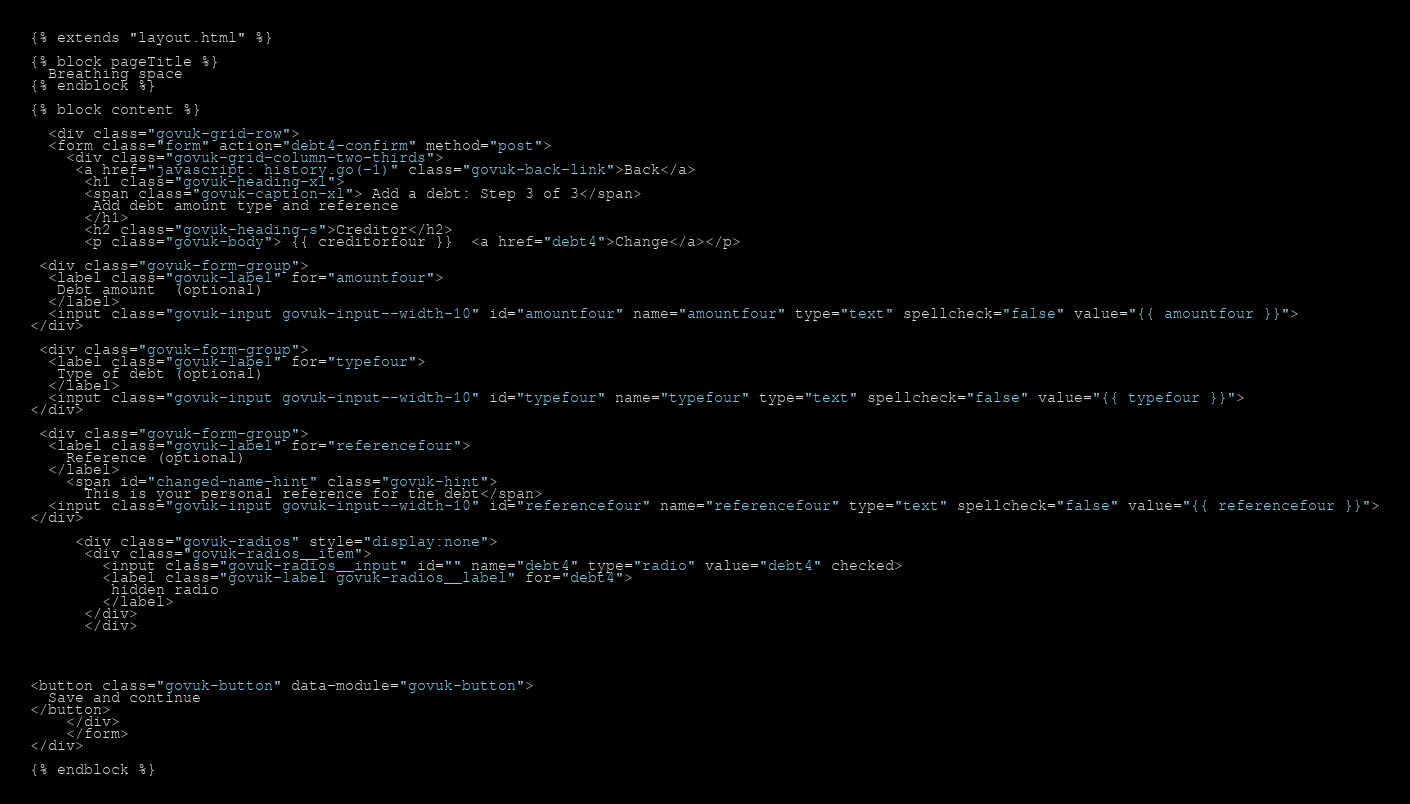Convert code to text. <code><loc_0><loc_0><loc_500><loc_500><_HTML_>
{% extends "layout.html" %}

{% block pageTitle %}
  Breathing space
{% endblock %}

{% block content %}

  <div class="govuk-grid-row">
  <form class="form" action="debt4-confirm" method="post">
    <div class="govuk-grid-column-two-thirds">
     <a href="javascript: history.go(-1)" class="govuk-back-link">Back</a>   
      <h1 class="govuk-heading-xl">
      <span class="govuk-caption-xl"> Add a debt: Step 3 of 3</span>
       Add debt amount type and reference
      </h1>
      <h2 class="govuk-heading-s">Creditor</h2>
      <p class="govuk-body"> {{ creditorfour }}  <a href="debt4">Change</a></p>

 <div class="govuk-form-group">
  <label class="govuk-label" for="amountfour">
   Debt amount  (optional)
  </label>
  <input class="govuk-input govuk-input--width-10" id="amountfour" name="amountfour" type="text" spellcheck="false" value="{{ amountfour }}">
</div>

 <div class="govuk-form-group">
  <label class="govuk-label" for="typefour">
   Type of debt (optional)
  </label>
  <input class="govuk-input govuk-input--width-10" id="typefour" name="typefour" type="text" spellcheck="false" value="{{ typefour }}">
</div>

 <div class="govuk-form-group">
  <label class="govuk-label" for="referencefour">
    Reference (optional)
  </label>
    <span id="changed-name-hint" class="govuk-hint">
      This is your personal reference for the debt</span>
  <input class="govuk-input govuk-input--width-10" id="referencefour" name="referencefour" type="text" spellcheck="false" value="{{ referencefour }}">
</div>

     <div class="govuk-radios" style="display:none">
      <div class="govuk-radios__item">
        <input class="govuk-radios__input" id="" name="debt4" type="radio" value="debt4" checked>
        <label class="govuk-label govuk-radios__label" for="debt4">
         hidden radio
        </label>
      </div>
      </div>




<button class="govuk-button" data-module="govuk-button">
  Save and continue
</button>
    </div>
    </form>
</div>

{% endblock %}
</code> 